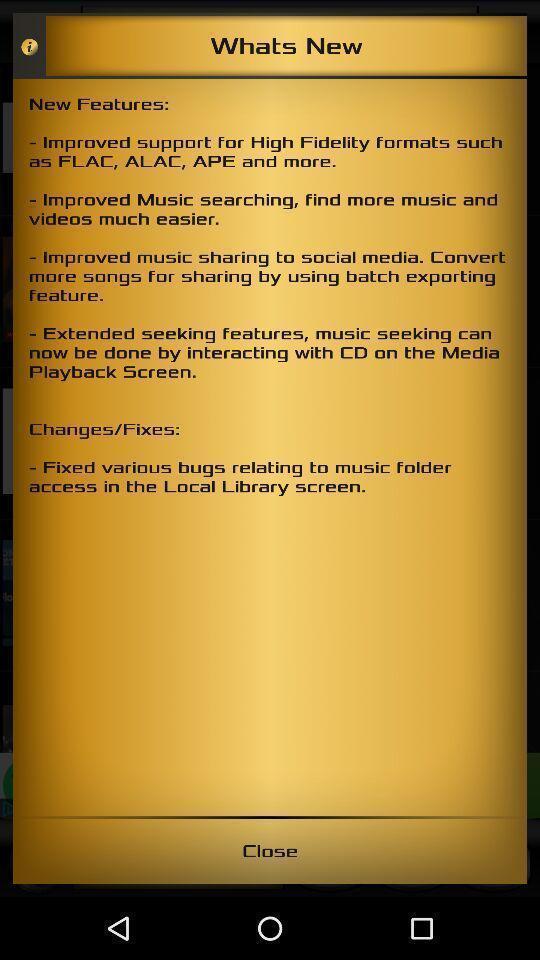Summarize the main components in this picture. Screen displaying multiple new features. 